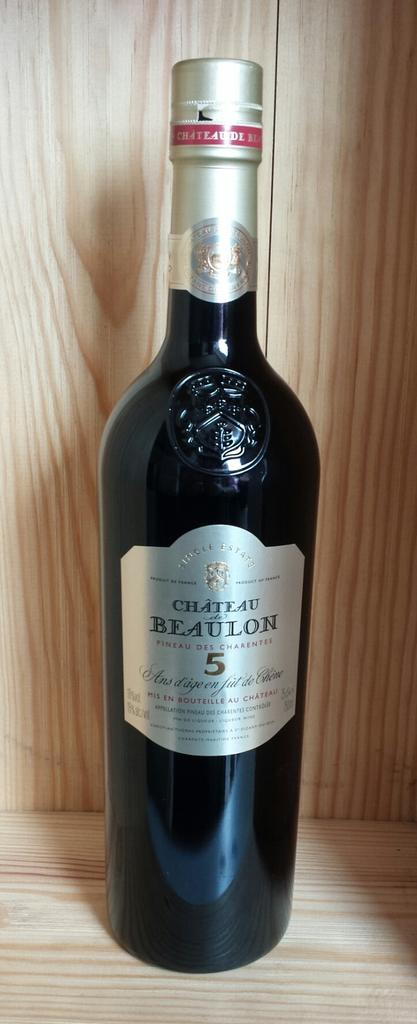Provide a one-sentence caption for the provided image. Bottle of wine with the words Beaulon 5 wrote on the front of it. 